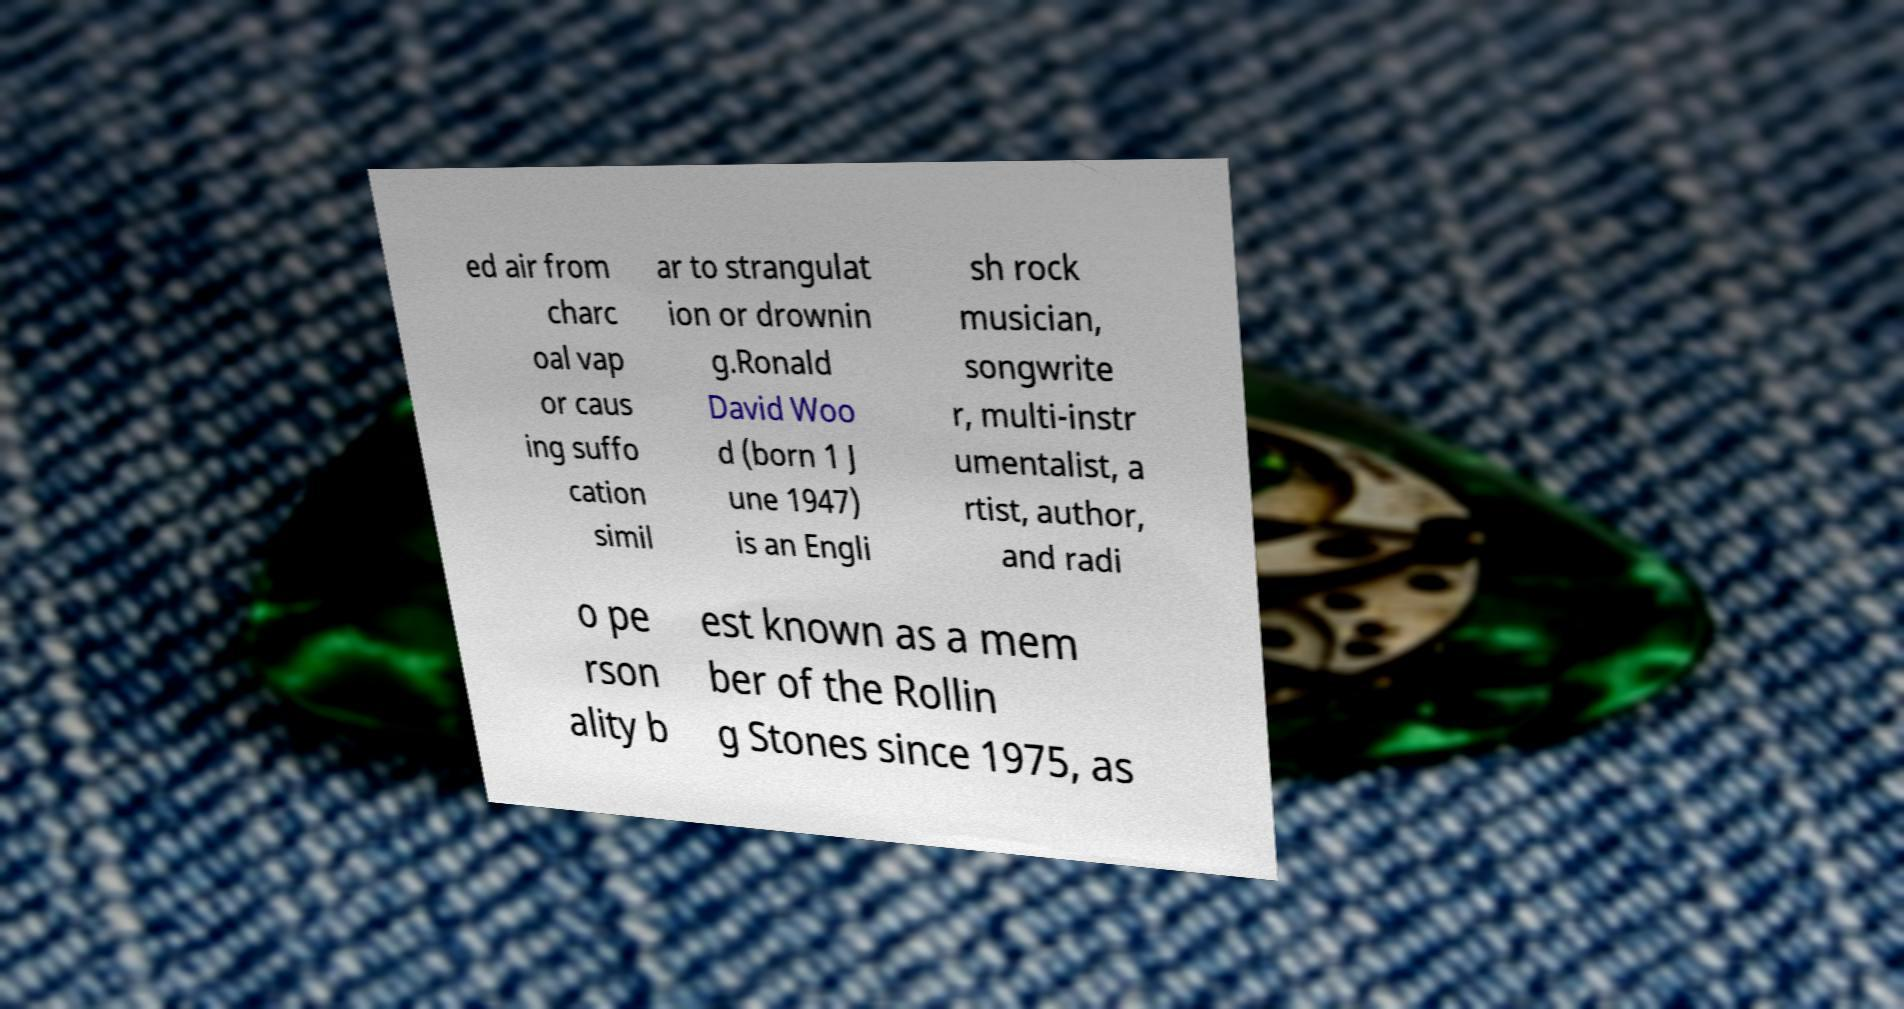Can you accurately transcribe the text from the provided image for me? ed air from charc oal vap or caus ing suffo cation simil ar to strangulat ion or drownin g.Ronald David Woo d (born 1 J une 1947) is an Engli sh rock musician, songwrite r, multi-instr umentalist, a rtist, author, and radi o pe rson ality b est known as a mem ber of the Rollin g Stones since 1975, as 